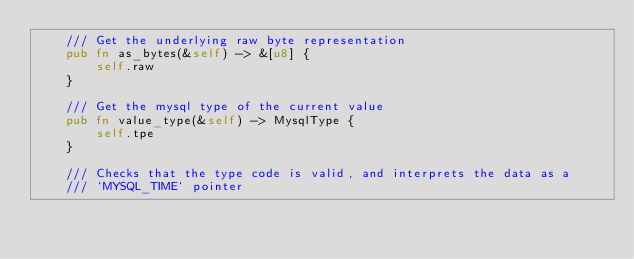<code> <loc_0><loc_0><loc_500><loc_500><_Rust_>    /// Get the underlying raw byte representation
    pub fn as_bytes(&self) -> &[u8] {
        self.raw
    }

    /// Get the mysql type of the current value
    pub fn value_type(&self) -> MysqlType {
        self.tpe
    }

    /// Checks that the type code is valid, and interprets the data as a
    /// `MYSQL_TIME` pointer</code> 